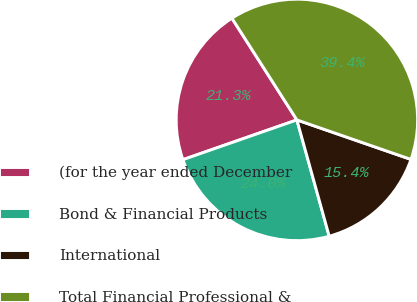Convert chart to OTSL. <chart><loc_0><loc_0><loc_500><loc_500><pie_chart><fcel>(for the year ended December<fcel>Bond & Financial Products<fcel>International<fcel>Total Financial Professional &<nl><fcel>21.29%<fcel>23.97%<fcel>15.38%<fcel>39.35%<nl></chart> 